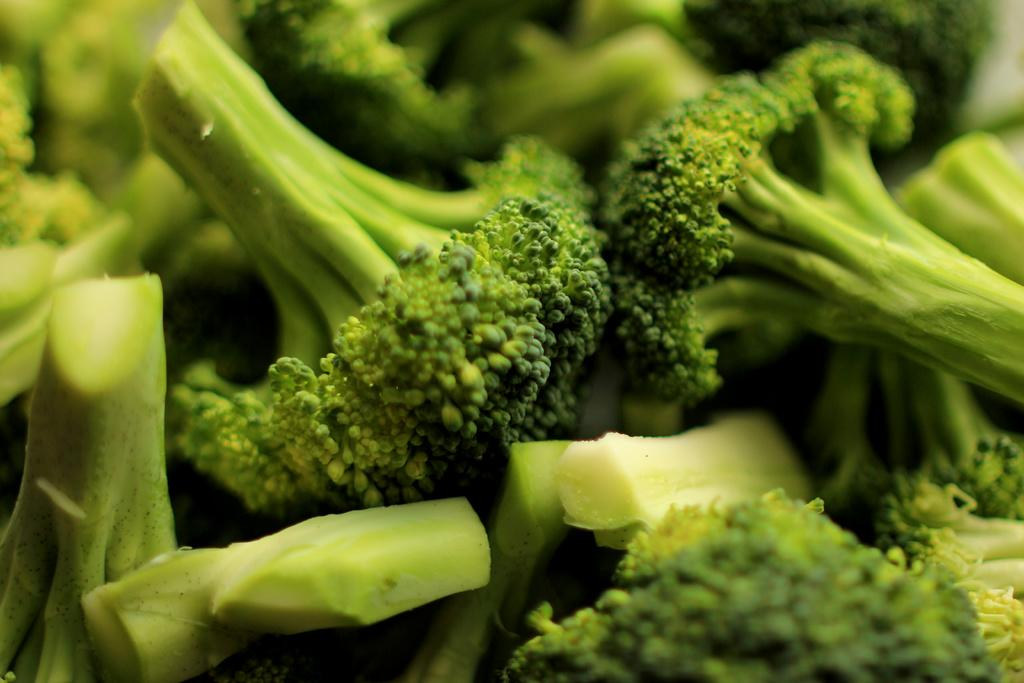What type of vegetable is present in the image? There are pieces of broccoli in the image. What is the mind made of in the image? There is no mention of a mind or any related objects in the image; it only contains pieces of broccoli. 